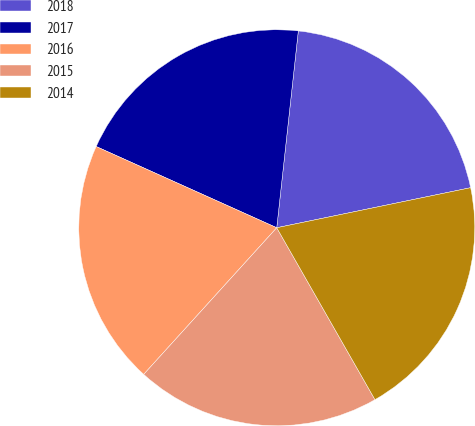<chart> <loc_0><loc_0><loc_500><loc_500><pie_chart><fcel>2018<fcel>2017<fcel>2016<fcel>2015<fcel>2014<nl><fcel>20.02%<fcel>20.01%<fcel>20.0%<fcel>19.99%<fcel>19.98%<nl></chart> 